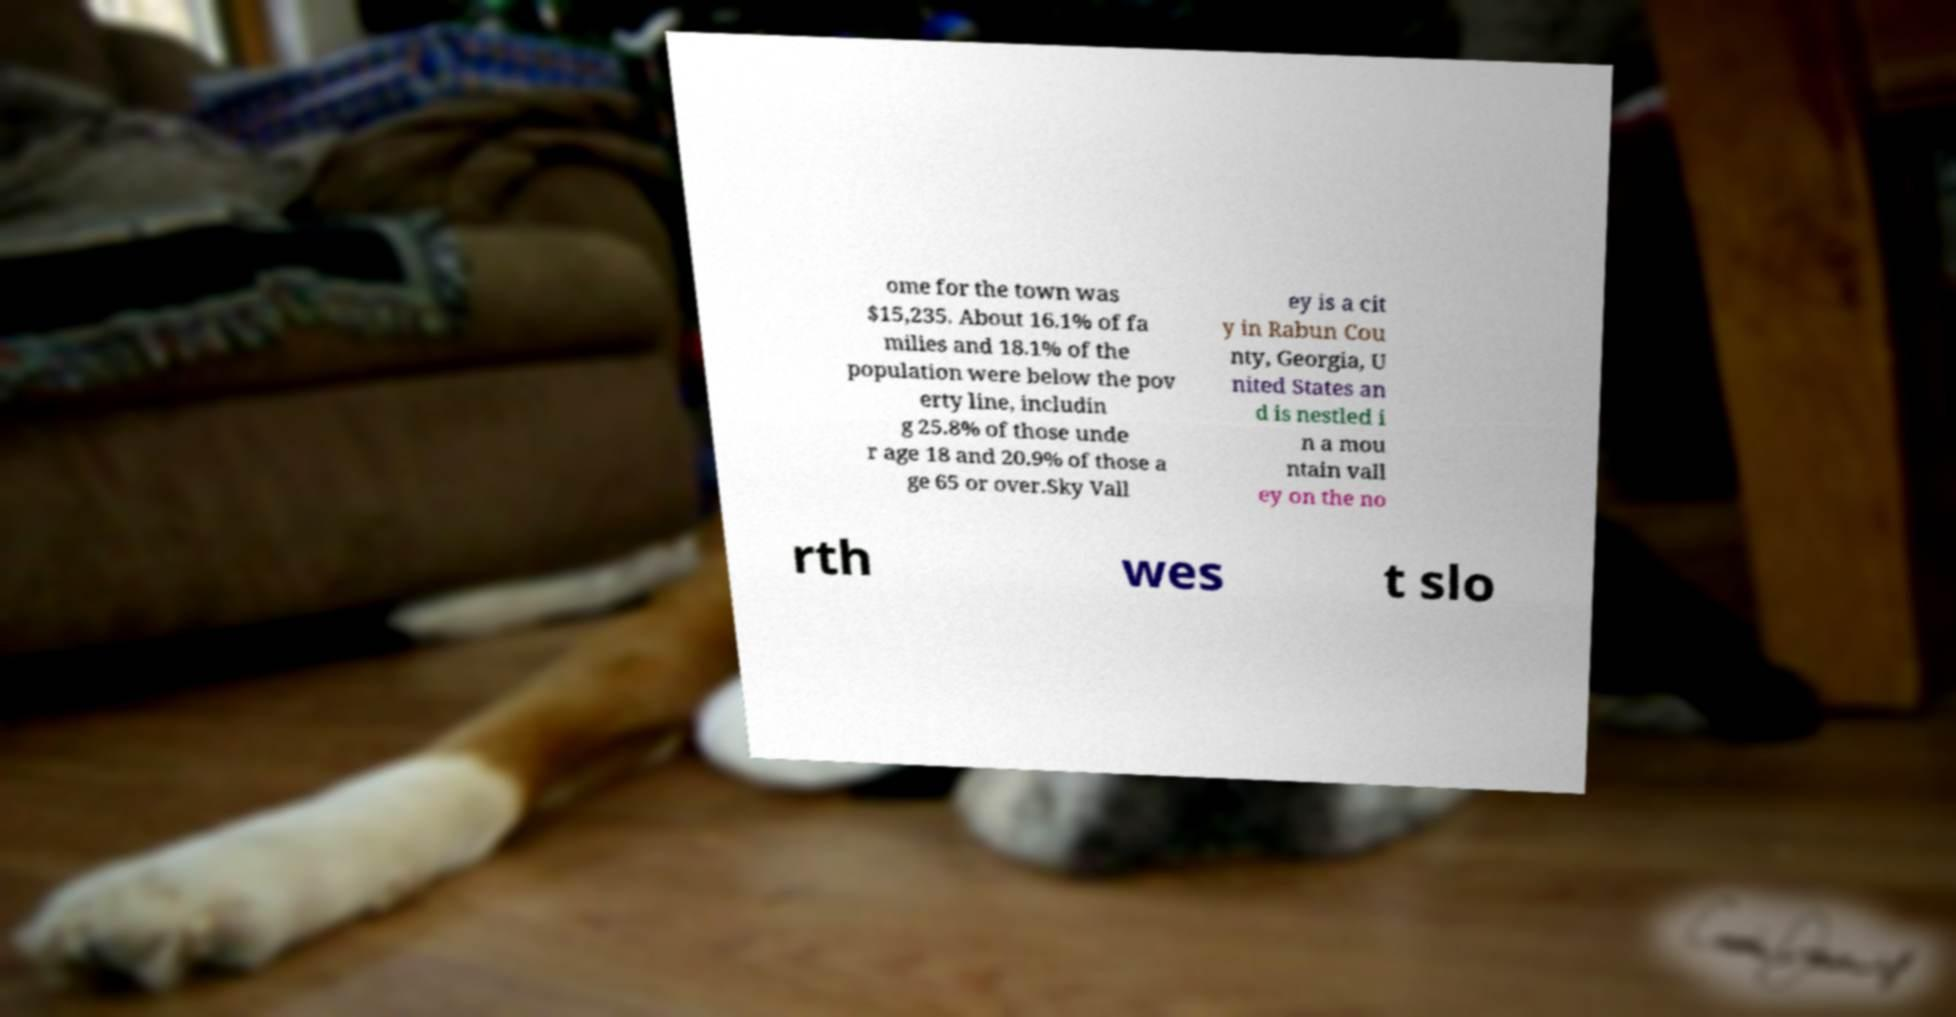There's text embedded in this image that I need extracted. Can you transcribe it verbatim? ome for the town was $15,235. About 16.1% of fa milies and 18.1% of the population were below the pov erty line, includin g 25.8% of those unde r age 18 and 20.9% of those a ge 65 or over.Sky Vall ey is a cit y in Rabun Cou nty, Georgia, U nited States an d is nestled i n a mou ntain vall ey on the no rth wes t slo 